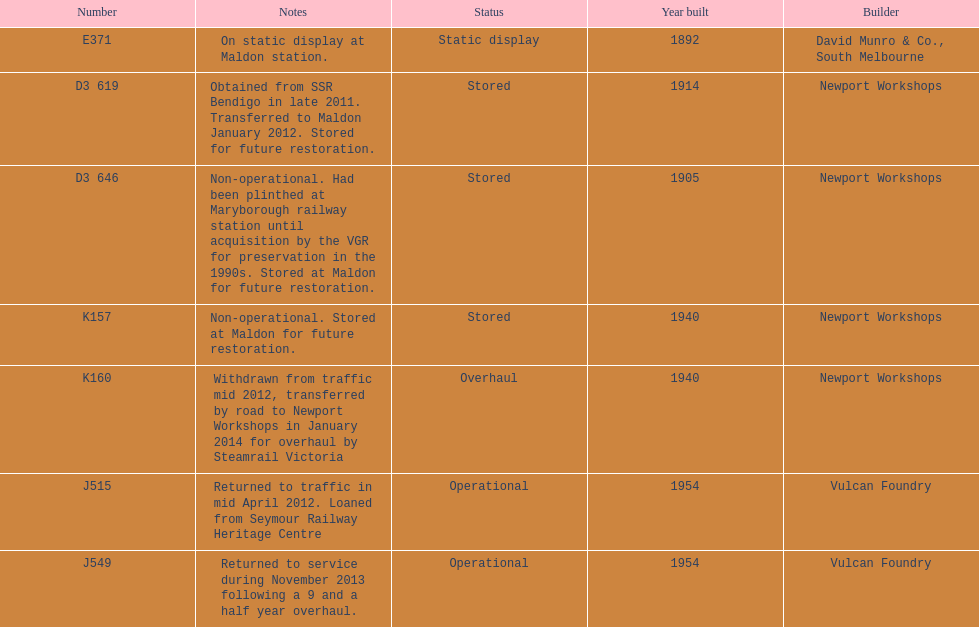Give me the full table as a dictionary. {'header': ['Number', 'Notes', 'Status', 'Year built', 'Builder'], 'rows': [['E371', 'On static display at Maldon station.', 'Static display', '1892', 'David Munro & Co., South Melbourne'], ['D3 619', 'Obtained from SSR Bendigo in late 2011. Transferred to Maldon January 2012. Stored for future restoration.', 'Stored', '1914', 'Newport Workshops'], ['D3 646', 'Non-operational. Had been plinthed at Maryborough railway station until acquisition by the VGR for preservation in the 1990s. Stored at Maldon for future restoration.', 'Stored', '1905', 'Newport Workshops'], ['K157', 'Non-operational. Stored at Maldon for future restoration.', 'Stored', '1940', 'Newport Workshops'], ['K160', 'Withdrawn from traffic mid 2012, transferred by road to Newport Workshops in January 2014 for overhaul by Steamrail Victoria', 'Overhaul', '1940', 'Newport Workshops'], ['J515', 'Returned to traffic in mid April 2012. Loaned from Seymour Railway Heritage Centre', 'Operational', '1954', 'Vulcan Foundry'], ['J549', 'Returned to service during November 2013 following a 9 and a half year overhaul.', 'Operational', '1954', 'Vulcan Foundry']]} Which are the only trains still in service? J515, J549. 